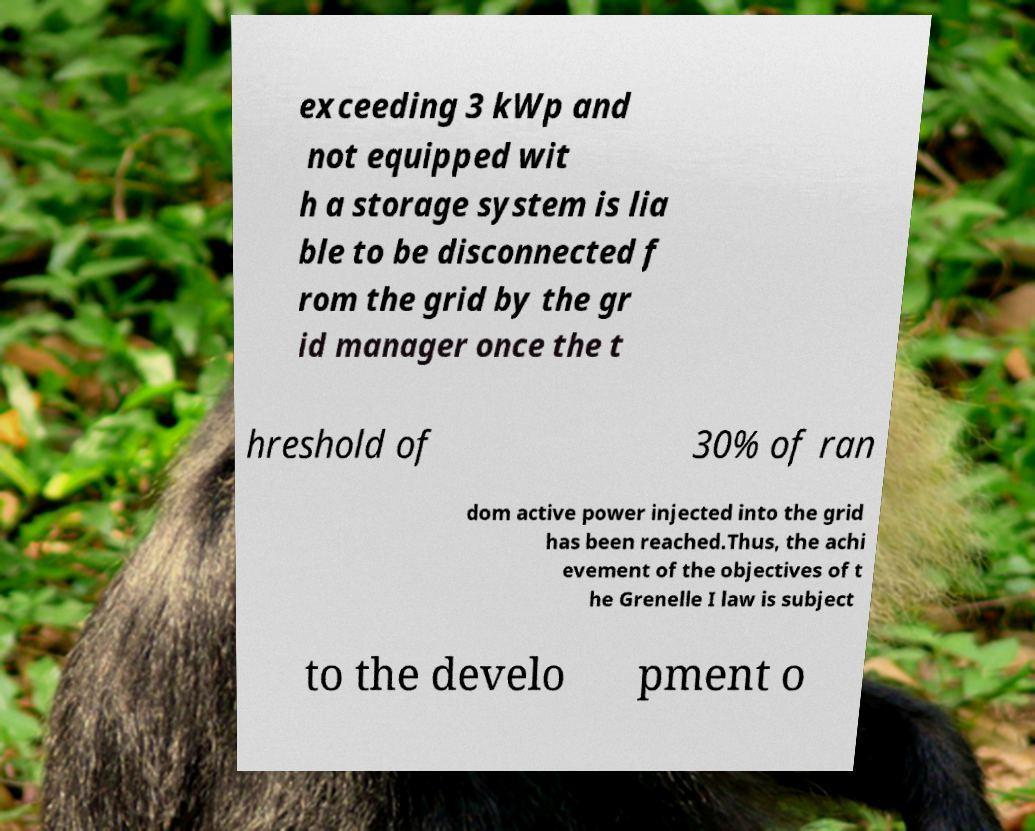Please read and relay the text visible in this image. What does it say? exceeding 3 kWp and not equipped wit h a storage system is lia ble to be disconnected f rom the grid by the gr id manager once the t hreshold of 30% of ran dom active power injected into the grid has been reached.Thus, the achi evement of the objectives of t he Grenelle I law is subject to the develo pment o 